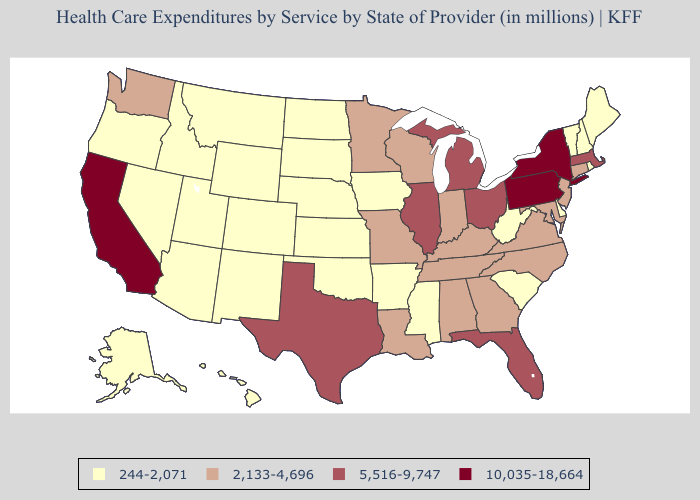Which states have the highest value in the USA?
Answer briefly. California, New York, Pennsylvania. Name the states that have a value in the range 5,516-9,747?
Keep it brief. Florida, Illinois, Massachusetts, Michigan, Ohio, Texas. What is the value of Texas?
Short answer required. 5,516-9,747. Name the states that have a value in the range 5,516-9,747?
Write a very short answer. Florida, Illinois, Massachusetts, Michigan, Ohio, Texas. Does New Mexico have the same value as California?
Give a very brief answer. No. Does Washington have the lowest value in the West?
Be succinct. No. Which states hav the highest value in the South?
Quick response, please. Florida, Texas. Name the states that have a value in the range 5,516-9,747?
Be succinct. Florida, Illinois, Massachusetts, Michigan, Ohio, Texas. Does Utah have a lower value than Virginia?
Quick response, please. Yes. How many symbols are there in the legend?
Write a very short answer. 4. Name the states that have a value in the range 244-2,071?
Short answer required. Alaska, Arizona, Arkansas, Colorado, Delaware, Hawaii, Idaho, Iowa, Kansas, Maine, Mississippi, Montana, Nebraska, Nevada, New Hampshire, New Mexico, North Dakota, Oklahoma, Oregon, Rhode Island, South Carolina, South Dakota, Utah, Vermont, West Virginia, Wyoming. What is the lowest value in states that border New Hampshire?
Answer briefly. 244-2,071. What is the lowest value in the MidWest?
Keep it brief. 244-2,071. Which states have the highest value in the USA?
Quick response, please. California, New York, Pennsylvania. What is the highest value in the MidWest ?
Concise answer only. 5,516-9,747. 